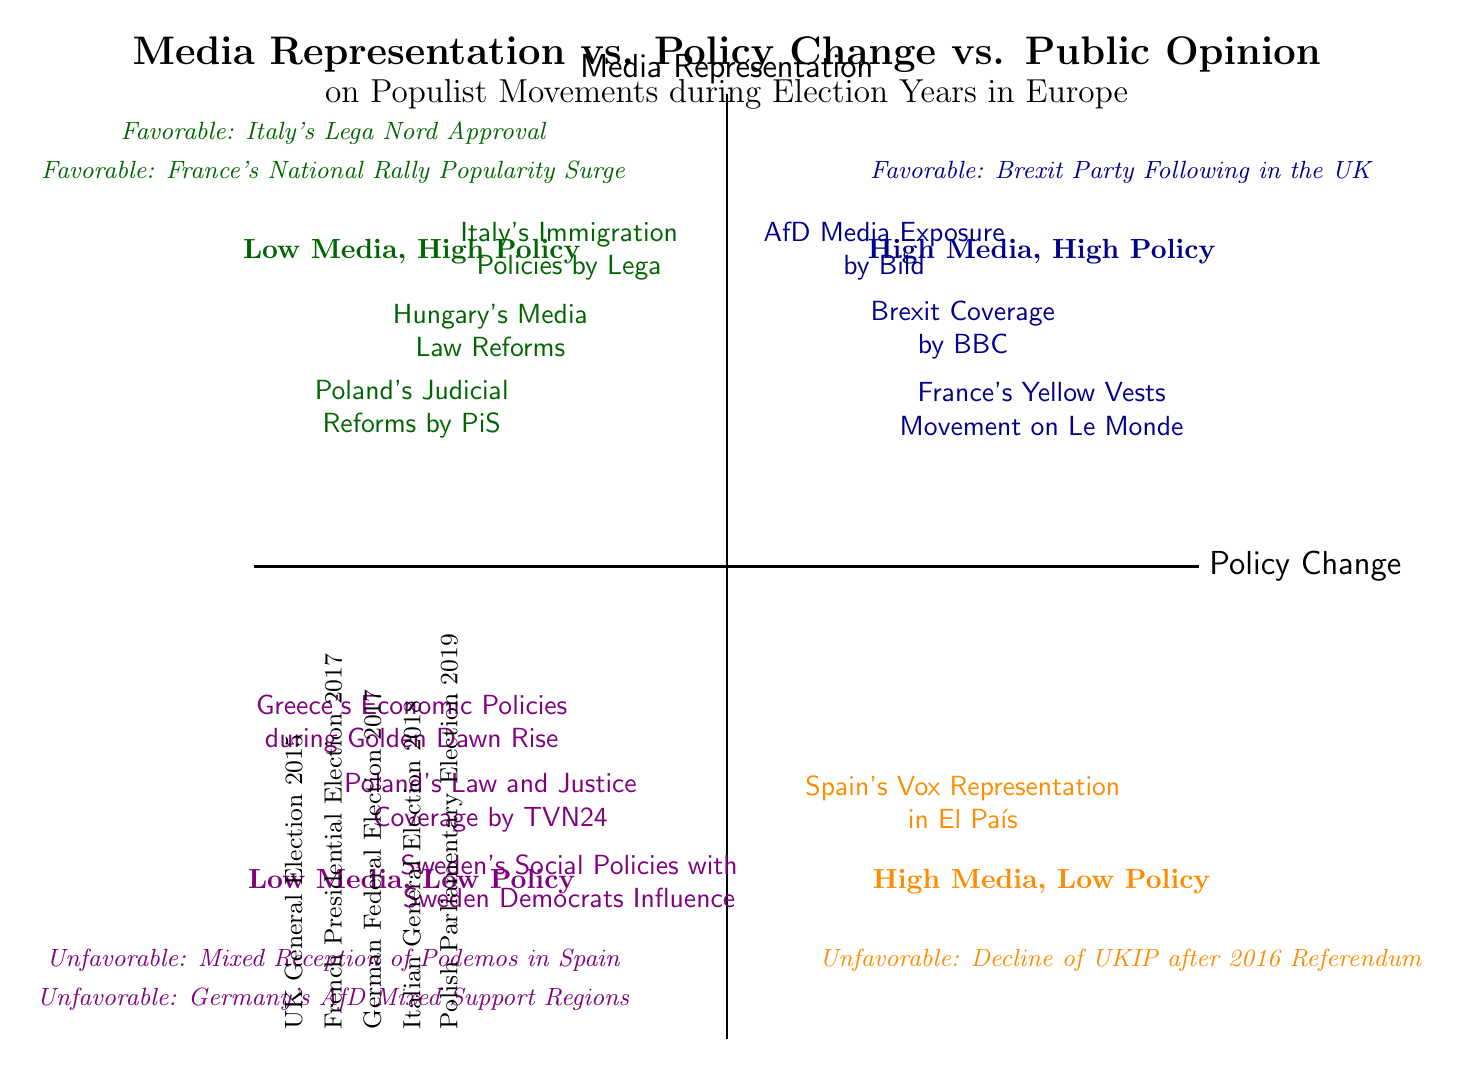What populist movement is represented with high media representation and high policy change? The diagram indicates that "Brexit Coverage by BBC" falls into the quadrant of high media representation and high policy change, alongside "Hungary's Media Law Reforms" and "Italy's Immigration Policies by Lega."
Answer: Brexit Coverage by BBC How many entries are listed under low media representation? The diagram shows that there are two entries under low media representation: "Spain's Vox Representation in El País" and "Poland's Law and Justice Coverage by TVN24."
Answer: 2 Which populist movement has an unfavorable public opinion? According to the diagram, the "Decline of UKIP after 2016 Referendum" is marked as having an unfavorable public opinion.
Answer: Decline of UKIP after 2016 Referendum What is the relationship between media representation and public opinion for Brexit? The diagram indicates that "Brexit Coverage by BBC" has high media representation and it is associated with favorable public opinion, specifically shown as "Favorable: Brexit Party Following in the UK." This relationship implies that high media coverage correlates with favorable public sentiment.
Answer: Favorable What is the significant policy change associated with Poland? The diagram identifies "Poland's Judicial Reforms by PiS" as a significant policy change associated with Poland that appears in the high policy quadrant.
Answer: Poland's Judicial Reforms by PiS Which quadrant contains favorable public opinion and low media representation? The quadrant that includes unfavorable public opinion with low media representation is identified as dark purple in the diagram. The specific movements listed here are "Mixed Reception of Podemos in Spain" and "Germany's AfD Mixed Support Regions."
Answer: Low Media, Low Policy How many populist movements are listed with high policy change? The diagram indicates there are three entries that exhibit high policy change: "Hungary's Media Law Reforms," "Italy's Immigration Policies by Lega," and "Poland's Judicial Reforms by PiS," thus summing to three.
Answer: 3 What does the presence of the "France's Yellow Vests Movement on Le Monde" signify about media representation? The presence of "France's Yellow Vests Movement on Le Monde" within the high media and high policy quadrant suggests that it received significant media coverage during its peak influence, indicating a strong representation in the media landscape at that time.
Answer: High Media Representation Which election year is associated with the "Italian General Election 2018"? The diagram associates the "Italian General Election 2018" with populist movements specifically during that election year, indicating it was a pivotal moment for populism in Italy.
Answer: Italian General Election 2018 